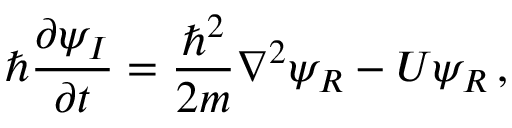Convert formula to latex. <formula><loc_0><loc_0><loc_500><loc_500>\hbar { } \partial \psi _ { I } } { \partial t } = \frac { \hbar { ^ } { 2 } } { 2 m } \nabla ^ { 2 } \psi _ { R } - U \psi _ { R } \, ,</formula> 